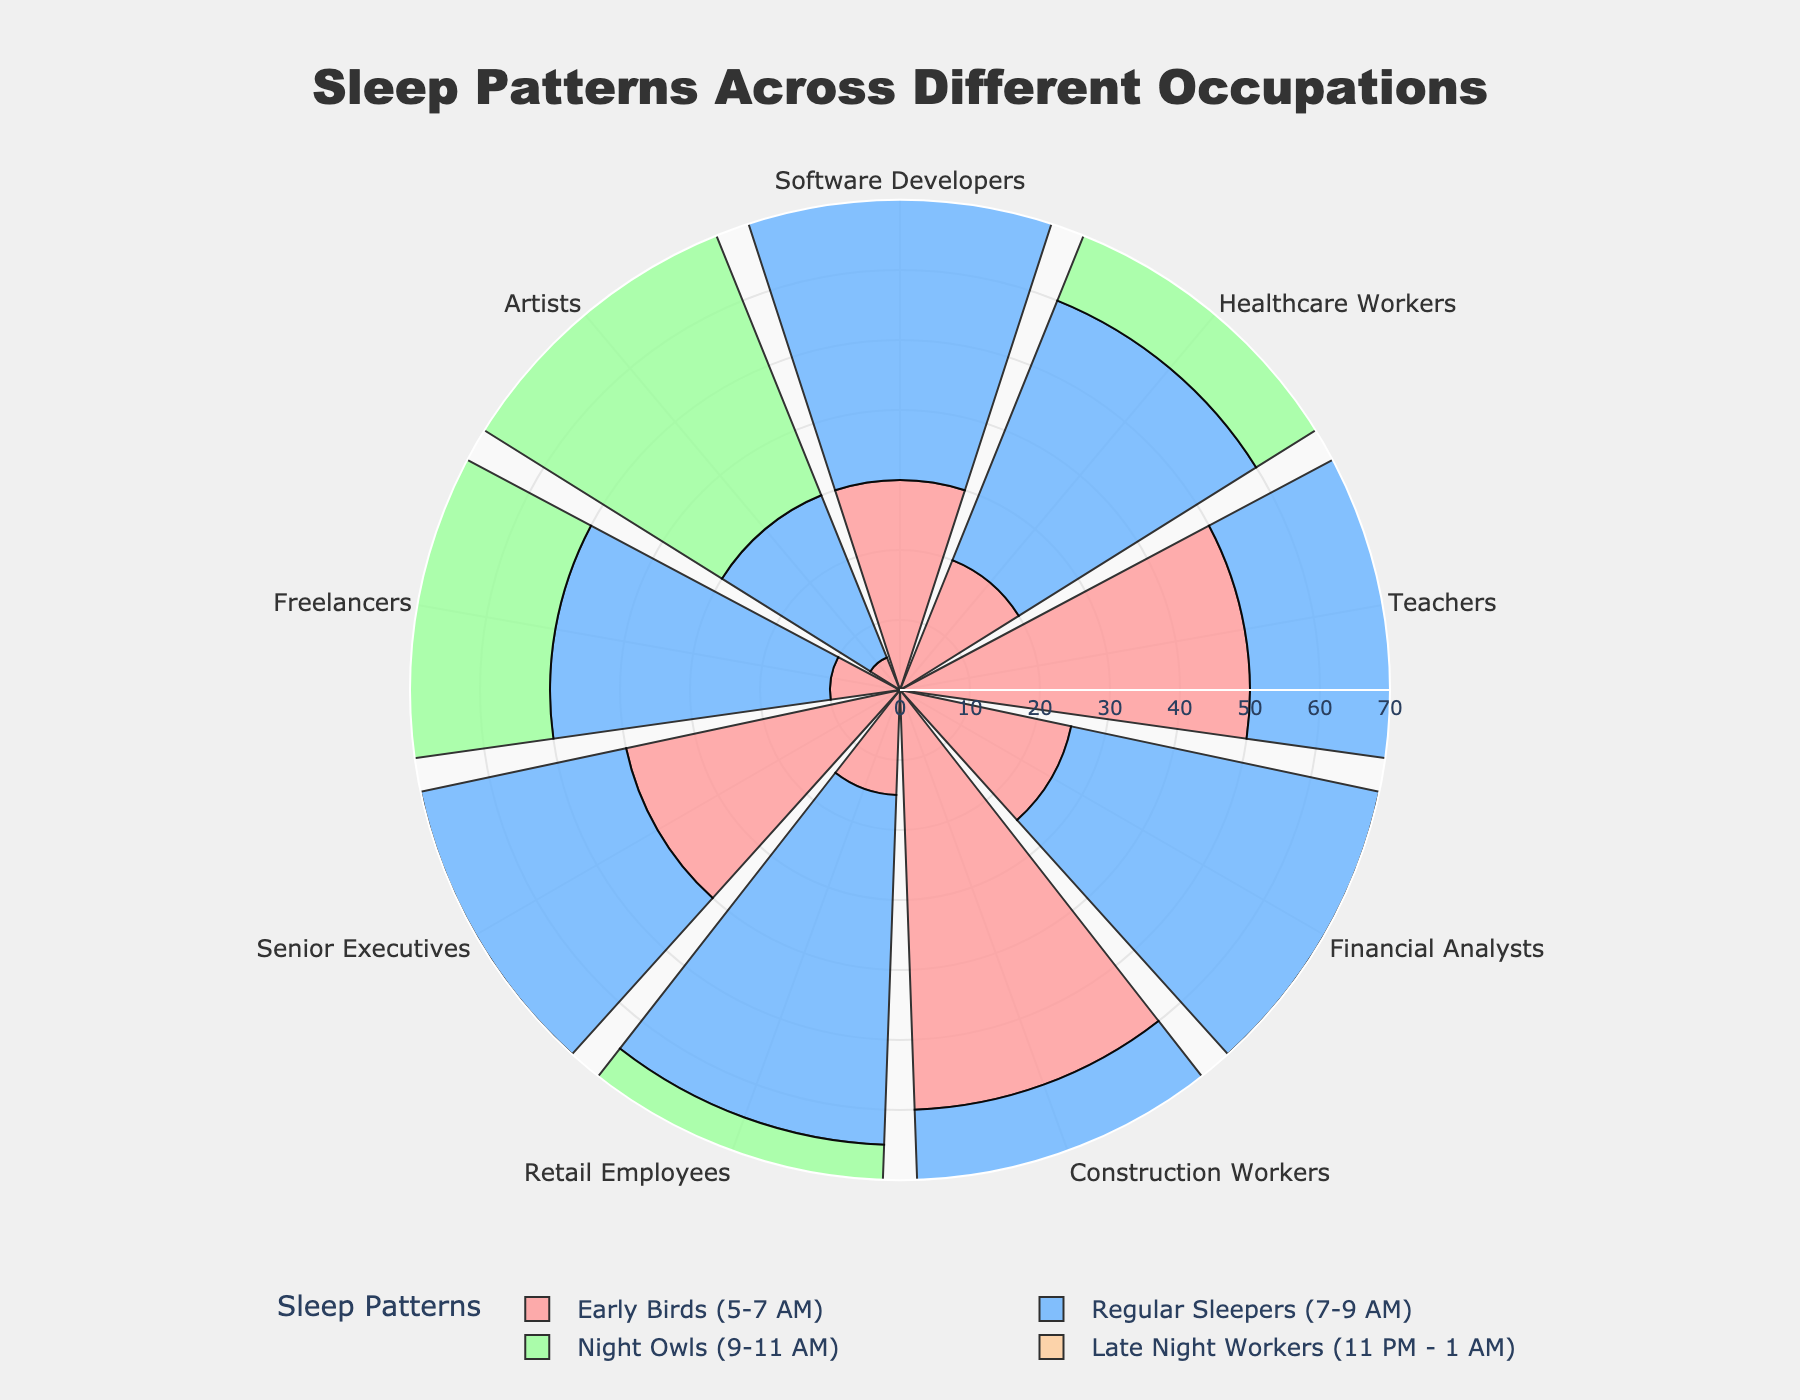What's the title of the plot? The title of the plot is displayed at the top of the figure as a textual element. The text of the title is designed to give an overview of what the figure represents.
Answer: Sleep Patterns Across Different Occupations What color represents "Early Birds (5-7 AM)" in the chart? The color representing each sleep pattern is mentioned in the legend, and the corresponding bars in the plot are colored in the same manner. For "Early Birds (5-7 AM)", the color is a shade of red.
Answer: Red Which occupation has the highest percentage of "Late Night Workers (11 PM - 1 AM)"? By visually inspecting the length of the radial bars corresponding to "Late Night Workers (11 PM - 1 AM)" segment for each occupation, we can see the proportion. Freelancers have the longest bar in that segment.
Answer: Freelancers How many occupations have more "Regular Sleepers (7-9 AM)" than "Early Birds (5-7 AM)"? By comparing the radial bar lengths for "Regular Sleepers (7-9 AM)" and "Early Birds (5-7 AM)" for each occupation, we find the ones where the "Regular Sleepers" bar is longer.
Answer: 6 What's the difference in percentage between "Early Birds (5-7 AM)" and "Night Owls (9-11 AM)" for Software Developers? The percentage for "Early Birds (5-7 AM)" is 30%, and for "Night Owls (9-11 AM)" is 15%. The difference is 30 - 15 = 15%.
Answer: 15% What is the total percentage of Teachers who are "Early Birds (5-7 AM)" and "Regular Sleepers (7-9 AM)"? Adding the percentages for "Early Birds (5-7 AM)" and "Regular Sleepers (7-9 AM)" in the Teachers occupation, we get 50 + 35 = 85%.
Answer: 85% Which occupation has the lowest percentage of "Early Birds (5-7 AM)"? By inspecting the radial bars for "Early Birds (5-7 AM)", the shortest bar belongs to Artists.
Answer: Artists How many occupations have at least 20% "Night Owls (9-11 AM)"? By checking the radial bars for "Night Owls (9-11 AM)" across all occupations, we find the ones with bars reaching at least 20%.
Answer: 6 For Senior Executives, which sleep pattern is most common? By looking at the radial bar lengths for each sleep pattern for Senior Executives, the tallest bar corresponds to "Early Birds (5-7 AM)".
Answer: Early Birds (5-7 AM) Compare the percentage of "Regular Sleepers (7-9 AM)" between Financial Analysts and Retail Employees. Who has the higher percentage? By comparing the radial bar lengths for "Regular Sleepers (7-9 AM)" between Financial Analysts and Retail Employees, Retail Employees have a longer bar indicating a higher percentage.
Answer: Retail Employees 